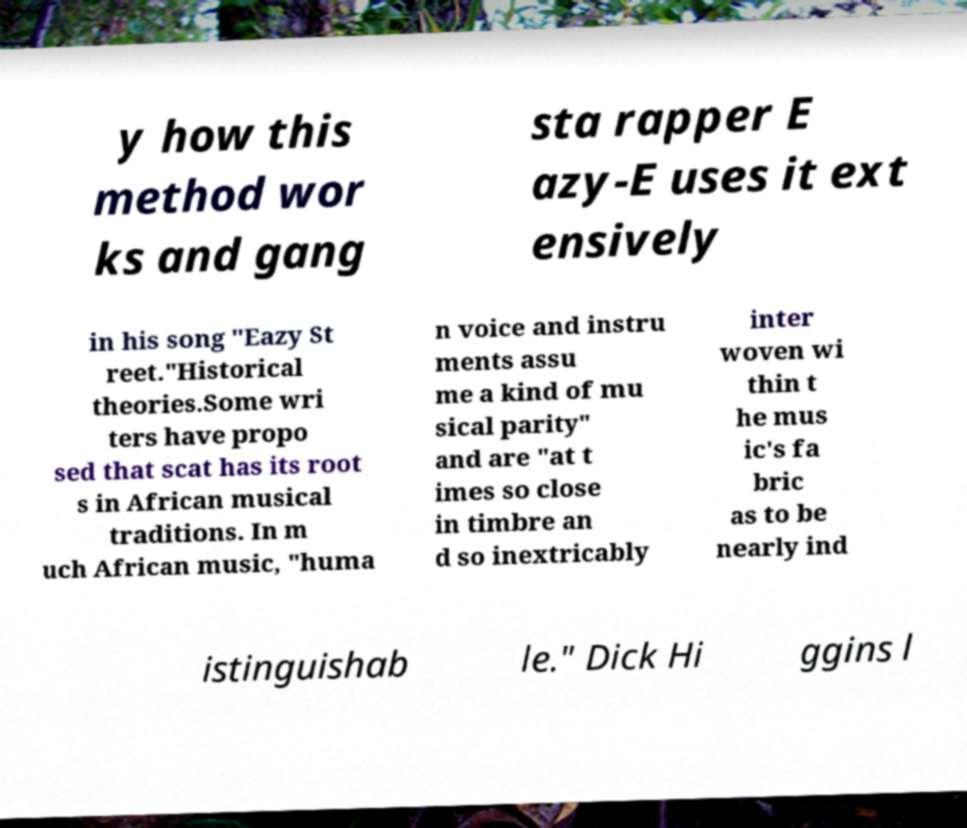Can you accurately transcribe the text from the provided image for me? y how this method wor ks and gang sta rapper E azy-E uses it ext ensively in his song "Eazy St reet."Historical theories.Some wri ters have propo sed that scat has its root s in African musical traditions. In m uch African music, "huma n voice and instru ments assu me a kind of mu sical parity" and are "at t imes so close in timbre an d so inextricably inter woven wi thin t he mus ic's fa bric as to be nearly ind istinguishab le." Dick Hi ggins l 